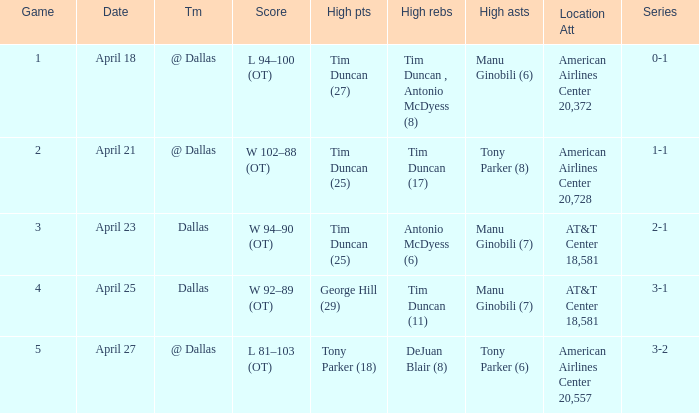When 5 is the game who has the highest amount of points? Tony Parker (18). 